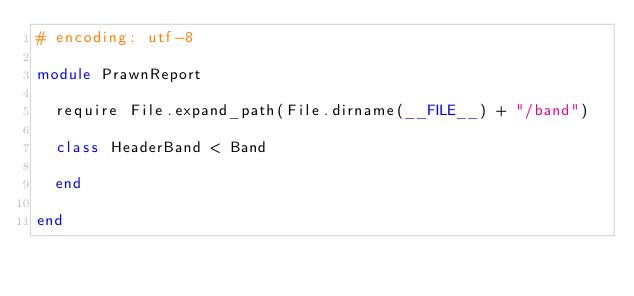<code> <loc_0><loc_0><loc_500><loc_500><_Ruby_># encoding: utf-8

module PrawnReport

  require File.expand_path(File.dirname(__FILE__) + "/band")

  class HeaderBand < Band

  end

end
</code> 